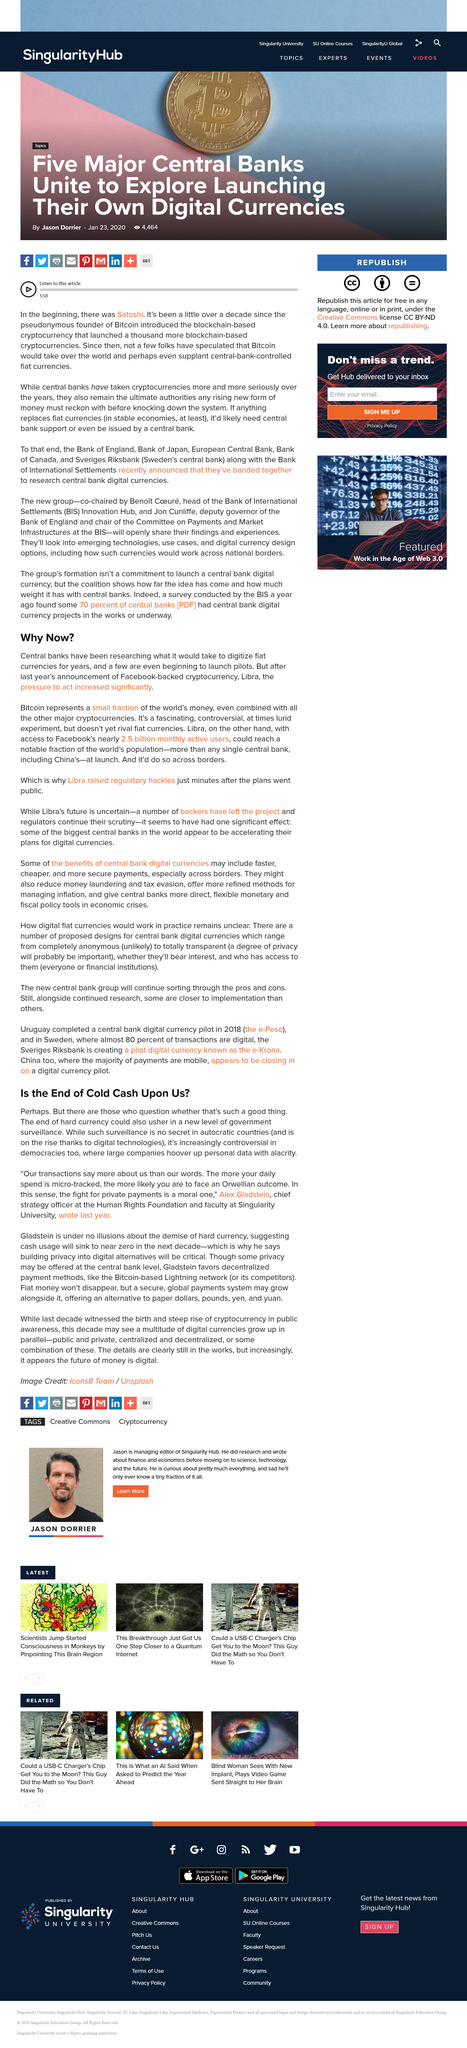Highlight a few significant elements in this photo. The end of hard currency will lead to a new era of government surveillance. Our transaction speak louder than our words, and they reveal more about us than what we can say. Yes, Bitcoin is a cryptocurrency. Alex Gladstein is the Chief Strategy Officer at the Human Rights Foundation and a faculty member at Singularity University. As of today, Facebook has almost 2.5 billion monthly active users. 